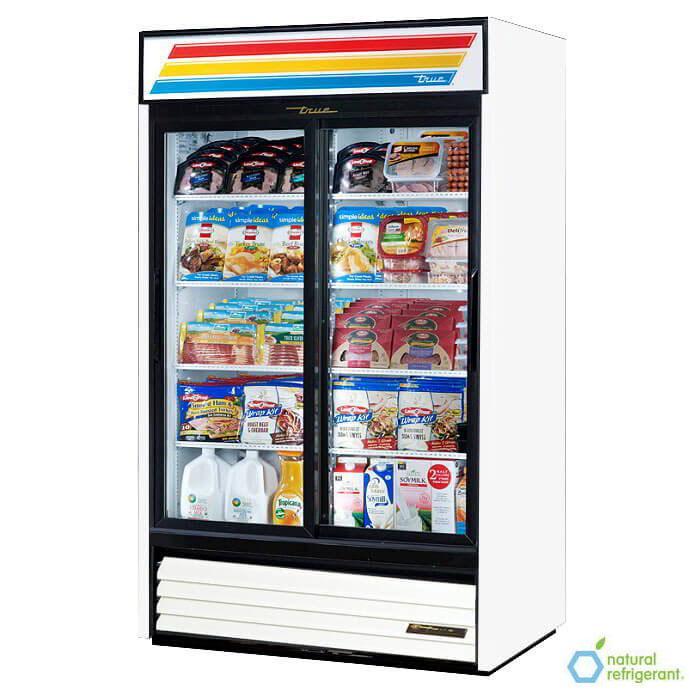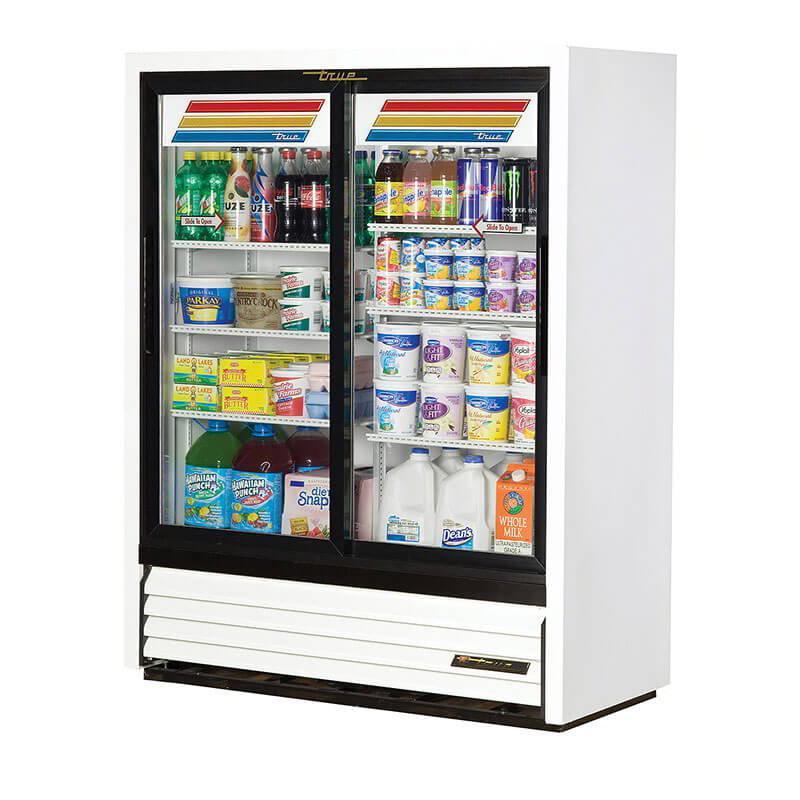The first image is the image on the left, the second image is the image on the right. Evaluate the accuracy of this statement regarding the images: "One image features a vending machine with an undivided band of three colors across the top.". Is it true? Answer yes or no. Yes. The first image is the image on the left, the second image is the image on the right. For the images shown, is this caption "Two vending machines are white with black trim and two large glass doors, but one has one set of three wide color stripes at the top, while the other has two sets of narrower color stripes." true? Answer yes or no. Yes. 